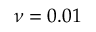<formula> <loc_0><loc_0><loc_500><loc_500>\nu = 0 . 0 1</formula> 